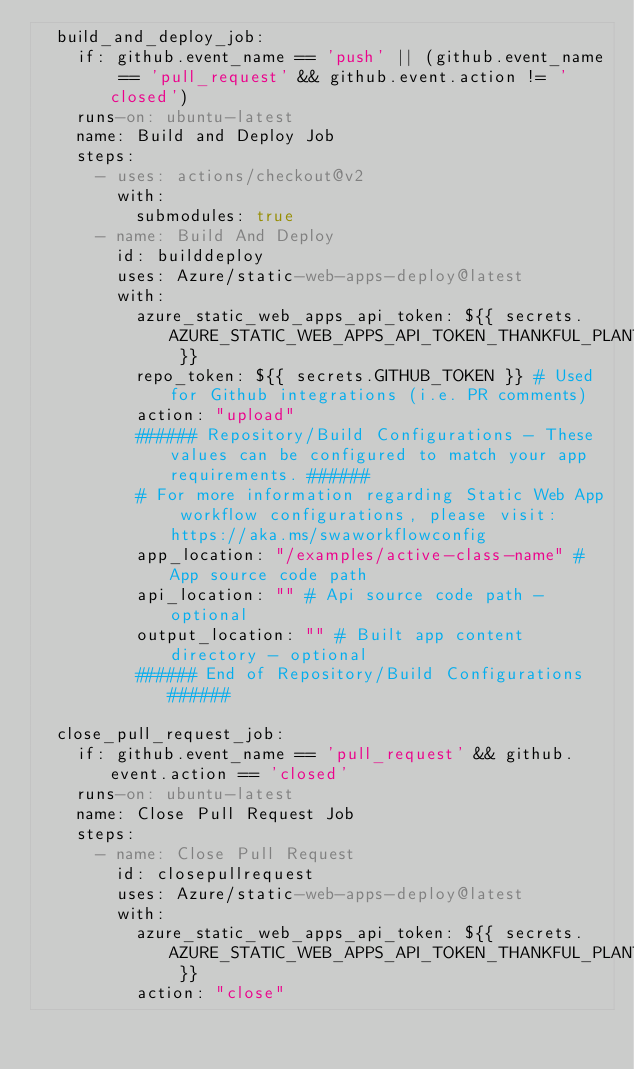Convert code to text. <code><loc_0><loc_0><loc_500><loc_500><_YAML_>  build_and_deploy_job:
    if: github.event_name == 'push' || (github.event_name == 'pull_request' && github.event.action != 'closed')
    runs-on: ubuntu-latest
    name: Build and Deploy Job
    steps:
      - uses: actions/checkout@v2
        with:
          submodules: true
      - name: Build And Deploy
        id: builddeploy
        uses: Azure/static-web-apps-deploy@latest
        with:
          azure_static_web_apps_api_token: ${{ secrets.AZURE_STATIC_WEB_APPS_API_TOKEN_THANKFUL_PLANT_03898A410 }}
          repo_token: ${{ secrets.GITHUB_TOKEN }} # Used for Github integrations (i.e. PR comments)
          action: "upload"
          ###### Repository/Build Configurations - These values can be configured to match your app requirements. ######
          # For more information regarding Static Web App workflow configurations, please visit: https://aka.ms/swaworkflowconfig
          app_location: "/examples/active-class-name" # App source code path
          api_location: "" # Api source code path - optional
          output_location: "" # Built app content directory - optional
          ###### End of Repository/Build Configurations ######

  close_pull_request_job:
    if: github.event_name == 'pull_request' && github.event.action == 'closed'
    runs-on: ubuntu-latest
    name: Close Pull Request Job
    steps:
      - name: Close Pull Request
        id: closepullrequest
        uses: Azure/static-web-apps-deploy@latest
        with:
          azure_static_web_apps_api_token: ${{ secrets.AZURE_STATIC_WEB_APPS_API_TOKEN_THANKFUL_PLANT_03898A410 }}
          action: "close"
</code> 